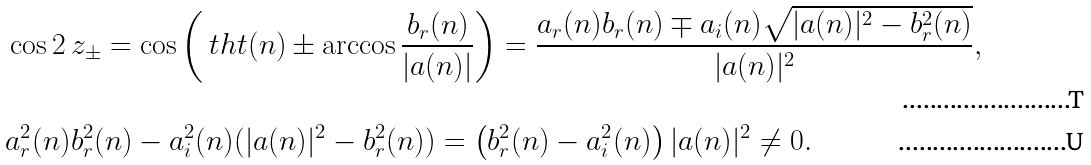Convert formula to latex. <formula><loc_0><loc_0><loc_500><loc_500>& \cos 2 \ z _ { \pm } = \cos \left ( \ t h t ( n ) \pm \arccos \frac { b _ { r } ( n ) } { | a ( n ) | } \right ) = \frac { a _ { r } ( n ) b _ { r } ( n ) \mp a _ { i } ( n ) \sqrt { | a ( n ) | ^ { 2 } - b _ { r } ^ { 2 } ( n ) } } { | a ( n ) | ^ { 2 } } , \\ & a _ { r } ^ { 2 } ( n ) b _ { r } ^ { 2 } ( n ) - a _ { i } ^ { 2 } ( n ) ( | a ( n ) | ^ { 2 } - b _ { r } ^ { 2 } ( n ) ) = \left ( b _ { r } ^ { 2 } ( n ) - a _ { i } ^ { 2 } ( n ) \right ) | a ( n ) | ^ { 2 } \ne 0 .</formula> 